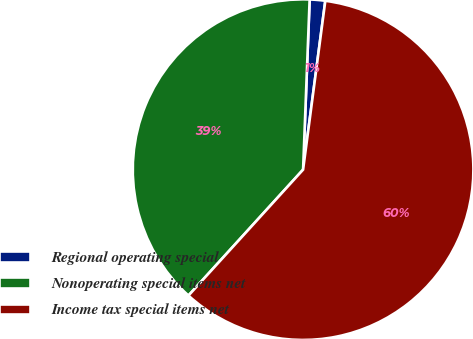Convert chart. <chart><loc_0><loc_0><loc_500><loc_500><pie_chart><fcel>Regional operating special<fcel>Nonoperating special items net<fcel>Income tax special items net<nl><fcel>1.47%<fcel>38.86%<fcel>59.67%<nl></chart> 